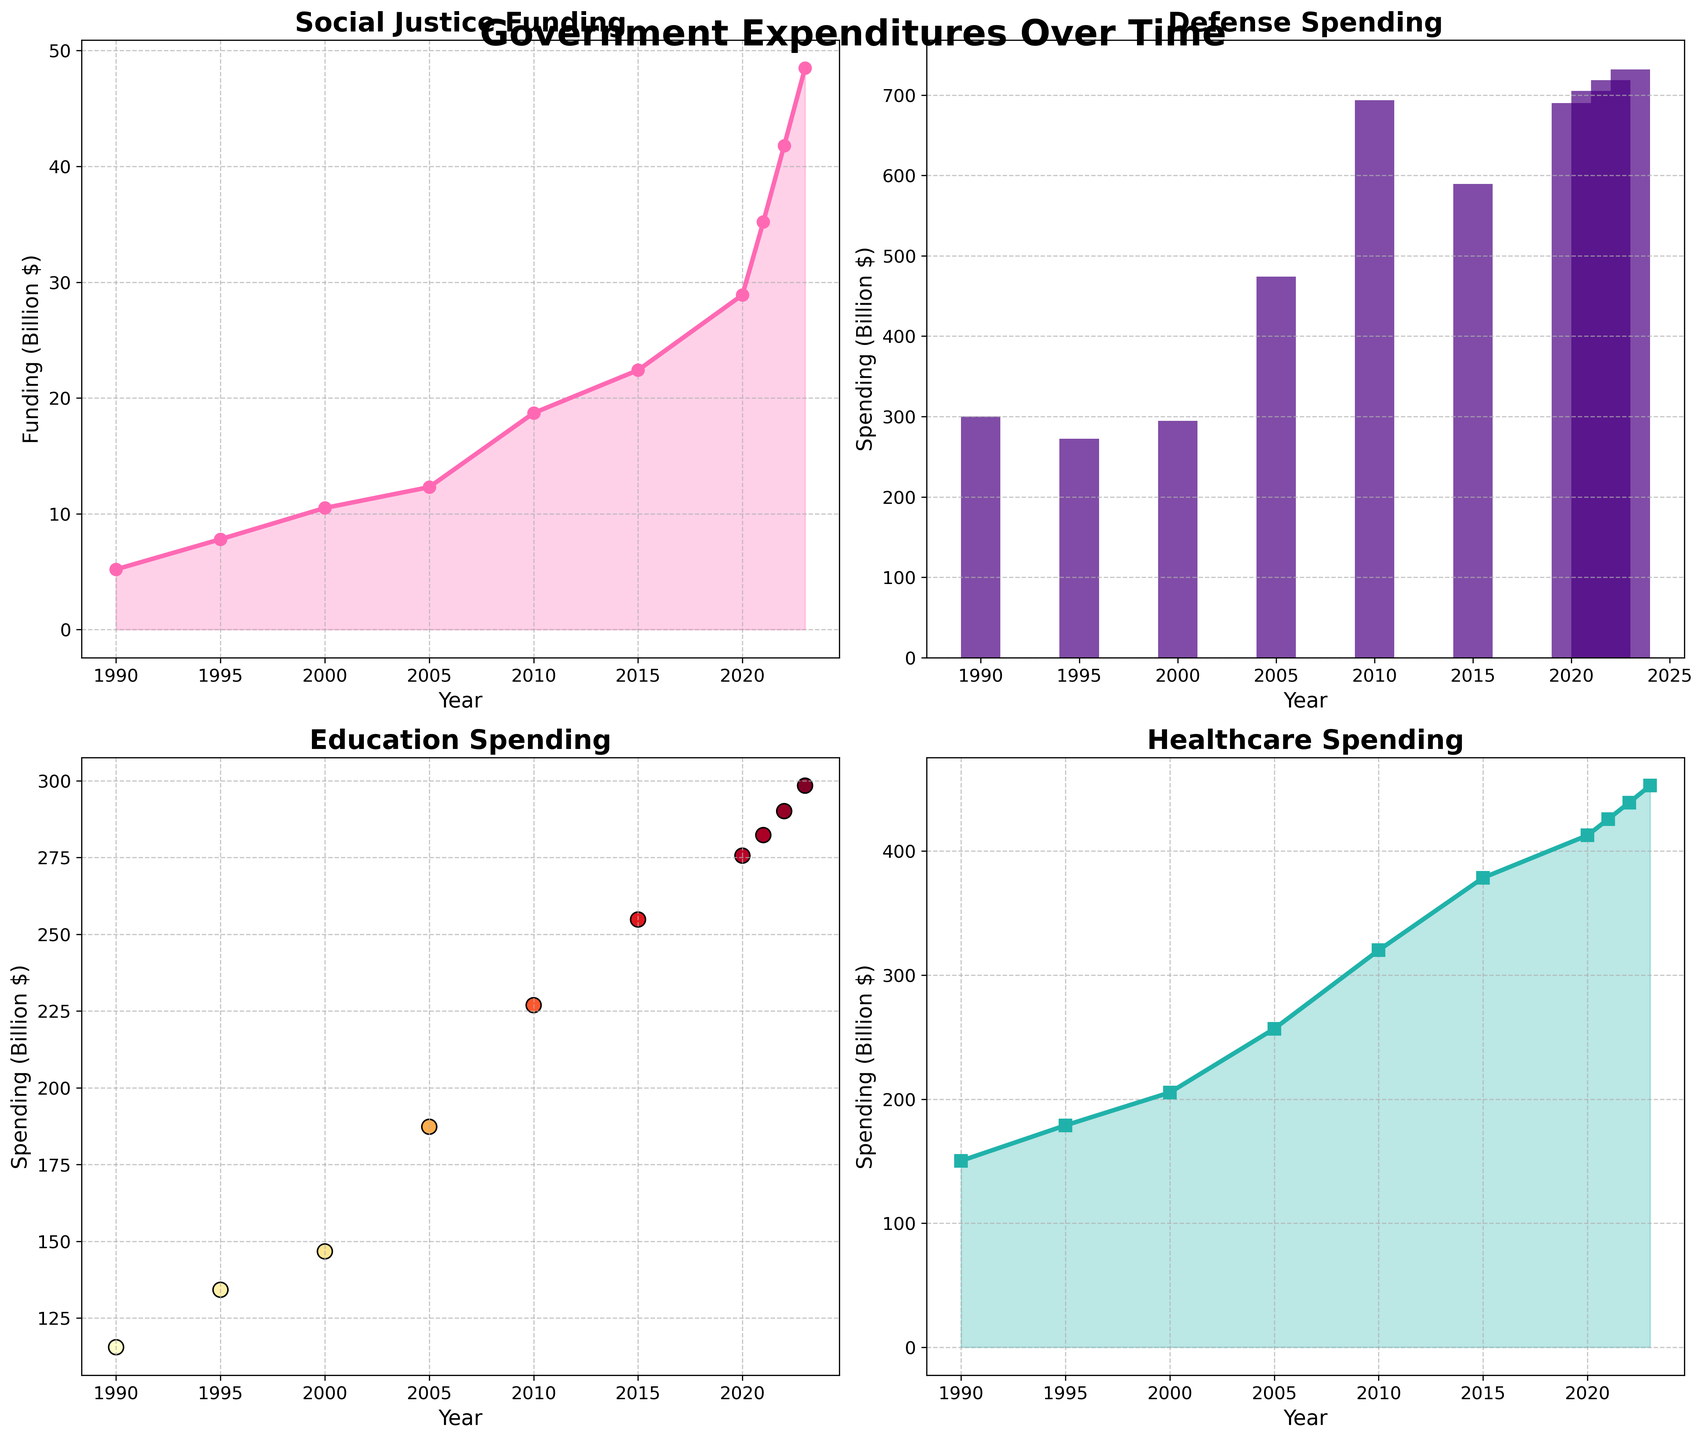What is the trend in Social Justice Funding from 1990 to 2023? The first plot shows Social Justice Funding over the years. The funding value starts at 5.2 billion dollars in 1990 and steadily increases to 48.5 billion dollars by 2023. This indicates a consistent upward trend.
Answer: Consistent upward trend Compare the spending on Defense and Education in 2010. Which was higher? In 2010, the height of the bar for Defense Spending is significantly taller than the size of the scatter point for Education Spending. The Defense Spending value is 693.5 billion dollars, whereas the Education Spending value is 226.9 billion dollars.
Answer: Defense Spending What is the average Education Spending for the years 2000, 2005, and 2010? The Education Spending values for the years 2000, 2005, and 2010 are 146.7, 187.3, and 226.9 billion dollars respectively. The sum is (146.7 + 187.3 + 226.9) = 560.9 billion dollars. To find the average, divide this sum by 3: 560.9 / 3 ≈ 187 billion dollars.
Answer: 187 billion dollars In which year did Social Justice Funding first exceed 30 billion dollars? The plot for Social Justice Funding shows an upward trend, and the funding value first exceeds 30 billion dollars in the year 2021, where it hits 35.2 billion dollars.
Answer: 2021 How much more was spent on Healthcare compared to Social Justice in 2023? In 2023, Healthcare Spending is plotted at 452.8 billion dollars, while Social Justice Funding is at 48.5 billion dollars. The difference is (452.8 - 48.5) = 404.3 billion dollars.
Answer: 404.3 billion dollars Which expenditure shows the most significant increase between 1990 and 2023? By observing the slopes of the lines and bars from 1990 to 2023, Defense Spending shows the most significant increase. It starts at 300.1 billion dollars in 1990 and reaches 732.1 billion dollars in 2023, an increase of 432 billion dollars.
Answer: Defense Spending What was the total government spending on Social Justice and Healthcare in 2020? In 2020, the Social Justice Funding value is 28.9 billion dollars and Healthcare Spending is 412.7 billion dollars. The sum is (28.9 + 412.7) = 441.6 billion dollars.
Answer: 441.6 billion dollars Is there any year where Education Spending was higher than Defense Spending? The bar plot for Defense Spending and scatter plot for Education Spending are compared, and in all years shown, the Defense Spending (represented by bars) was higher than Education Spending (represented by scatter points).
Answer: No Which year had the smallest difference between Defense Spending and Social Justice Funding? Calculating the differences for each year and checking the smallest, the year 1995 had Defense Spending at 272.3 billion dollars and Social Justice Funding at 7.8 billion dollars. The difference is (272.3 - 7.8) = 264.5 billion dollars, which is the smallest when comparing to other years.
Answer: 1995 What pattern can you observe in Healthcare Spending from 1990 to 2023? The Healthcare Spending plot shows a steady increase over the years: from 150.3 billion dollars in 1990 to 452.8 billion dollars in 2023, indicating a consistent upward trend.
Answer: Consistent upward trend 